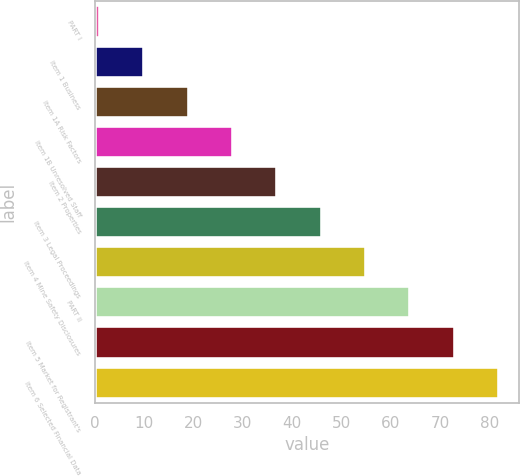Convert chart. <chart><loc_0><loc_0><loc_500><loc_500><bar_chart><fcel>PART I<fcel>Item 1 Business<fcel>Item 1A Risk Factors<fcel>Item 1B Unresolved Staff<fcel>Item 2 Properties<fcel>Item 3 Legal Proceedings<fcel>Item 4 Mine Safety Disclosures<fcel>PART II<fcel>Item 5 Market for Registrant's<fcel>Item 6 Selected Financial Data<nl><fcel>1<fcel>10<fcel>19<fcel>28<fcel>37<fcel>46<fcel>55<fcel>64<fcel>73<fcel>82<nl></chart> 